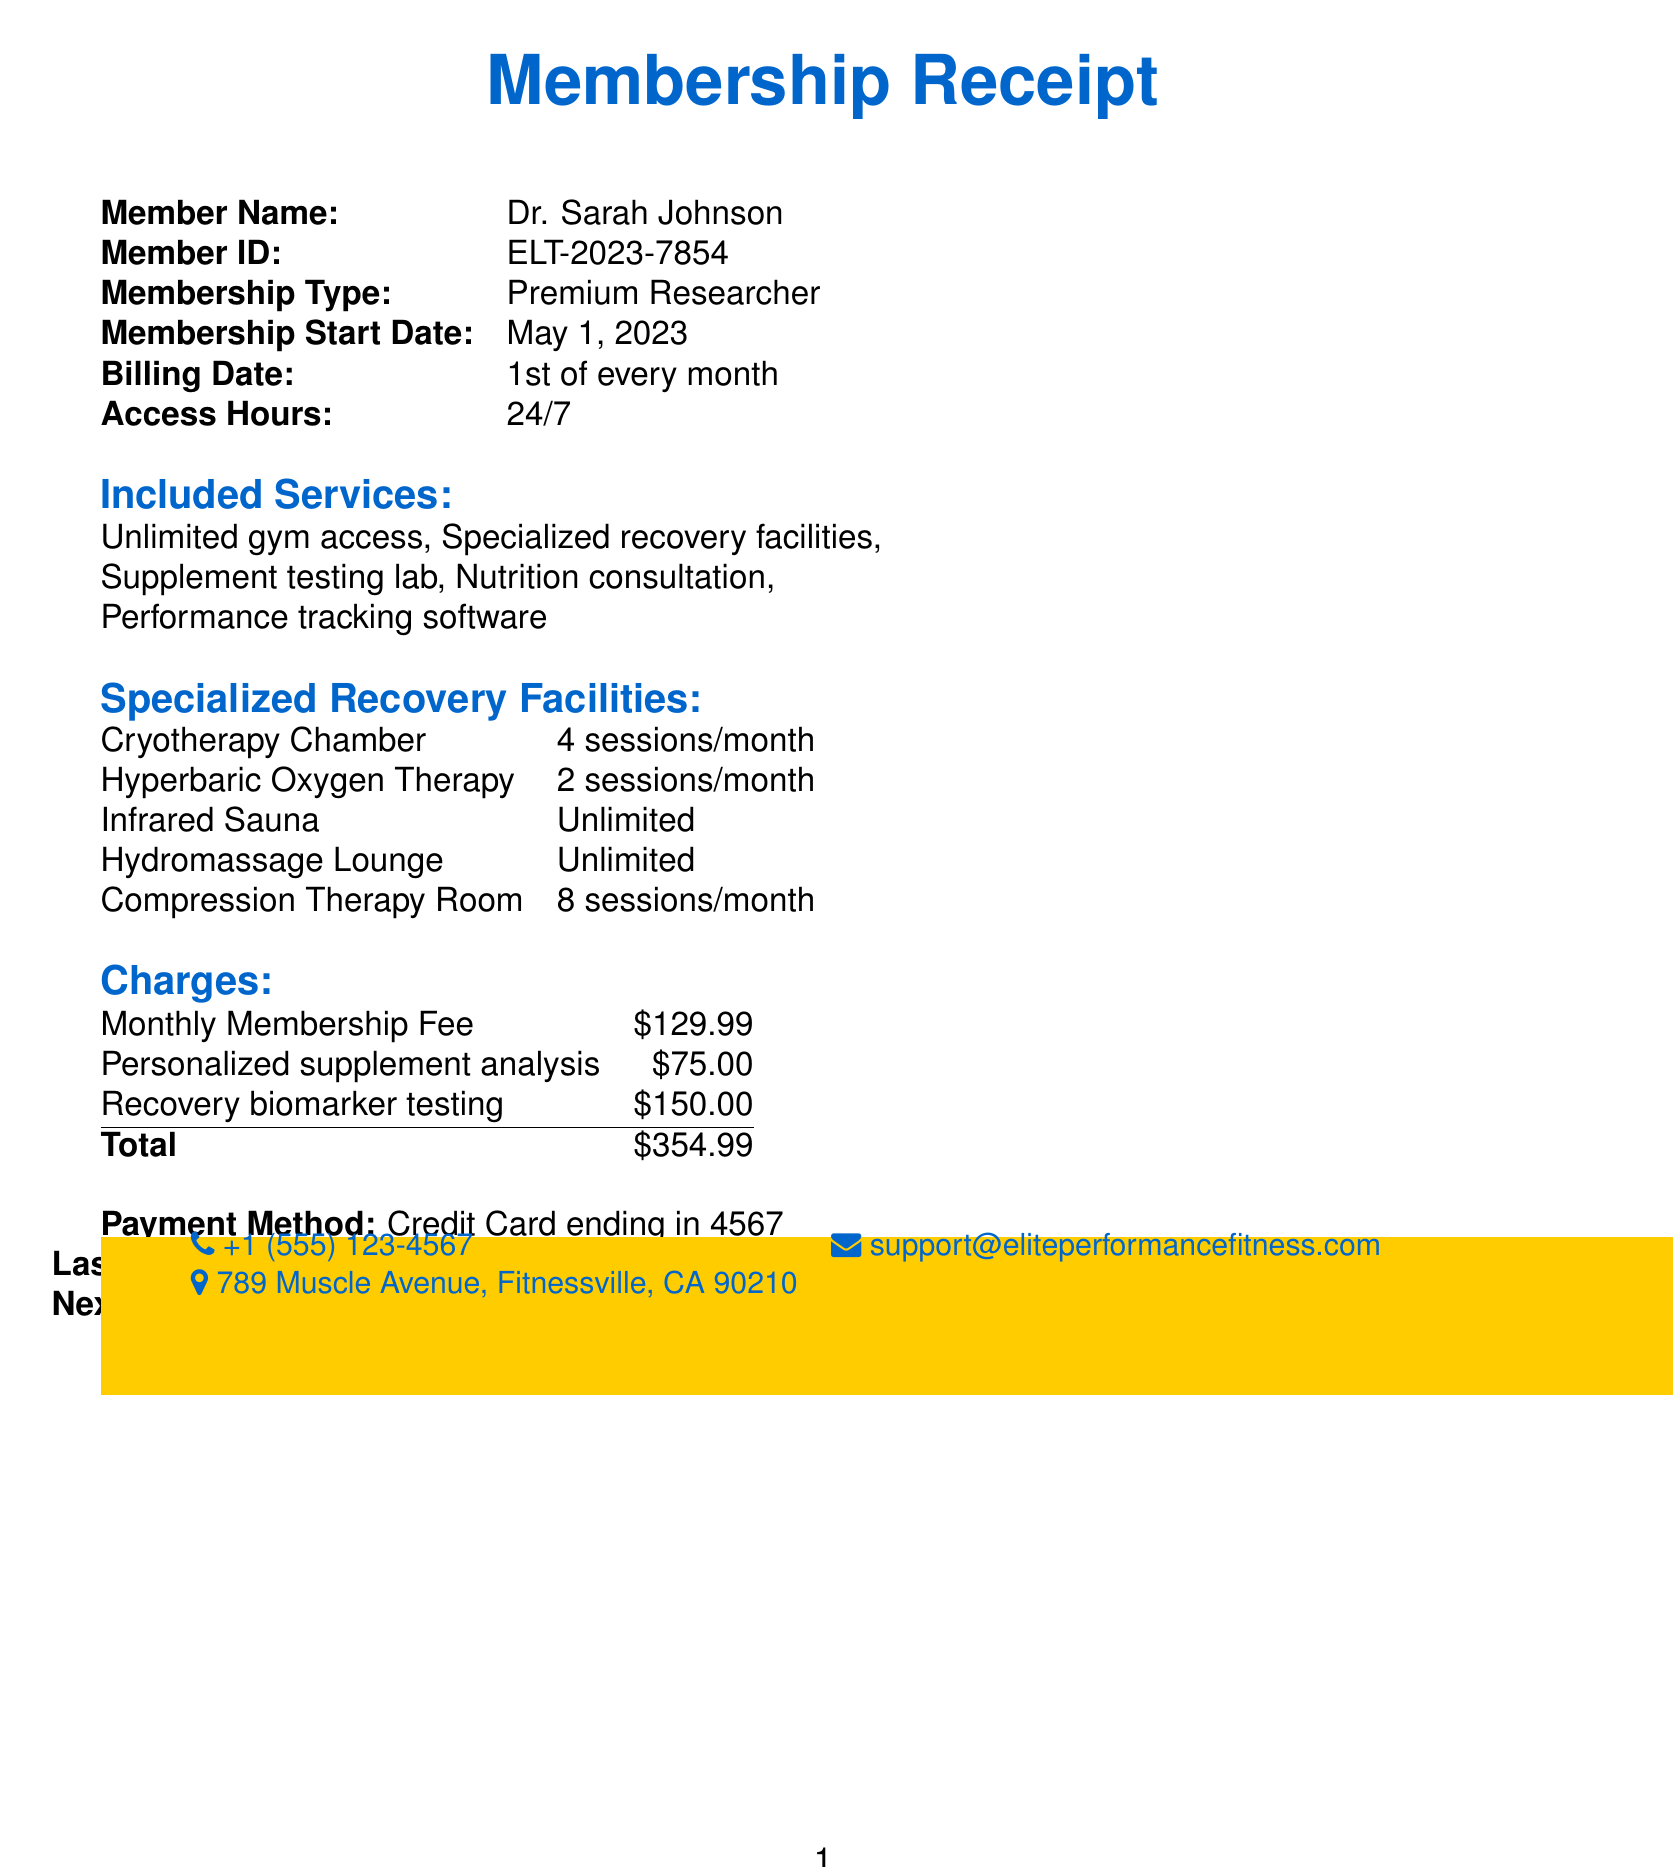What is the name of the gym? The name of the gym is listed at the top of the receipt.
Answer: Elite Performance Fitness Center What is the monthly fee for the membership? The monthly fee is clearly stated in the charges section of the receipt.
Answer: $129.99 How many sessions of Cryotherapy Chamber are included per month? The number of sessions for the Cryotherapy Chamber is specified in the specialized recovery facilities section.
Answer: 4 sessions/month When does the next payment date occur? The next payment date is listed in the payment information section of the receipt.
Answer: July 1, 2023 What is included in the membership services? This can be found in the included services section, which lists all the services available to the member.
Answer: Unlimited gym access, Specialized recovery facilities, Supplement testing lab, Nutrition consultation, Performance tracking software How many sessions of Compression Therapy Room are allowed per month? This number is noted in the specialized recovery facilities section of the receipt.
Answer: 8 sessions/month What is the fee for the personalized supplement analysis? The fee for this specific service is included in the additional charges section.
Answer: $75.00 What type of membership does Dr. Sarah Johnson have? The receipt specifies the membership type associated with the member.
Answer: Premium Researcher What is the address of the gym? The address of the gym is provided in the customer support section of the receipt.
Answer: 789 Muscle Avenue, Fitnessville, CA 90210 